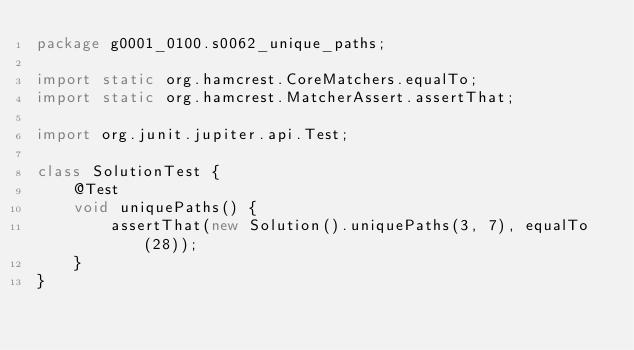Convert code to text. <code><loc_0><loc_0><loc_500><loc_500><_Java_>package g0001_0100.s0062_unique_paths;

import static org.hamcrest.CoreMatchers.equalTo;
import static org.hamcrest.MatcherAssert.assertThat;

import org.junit.jupiter.api.Test;

class SolutionTest {
    @Test
    void uniquePaths() {
        assertThat(new Solution().uniquePaths(3, 7), equalTo(28));
    }
}
</code> 